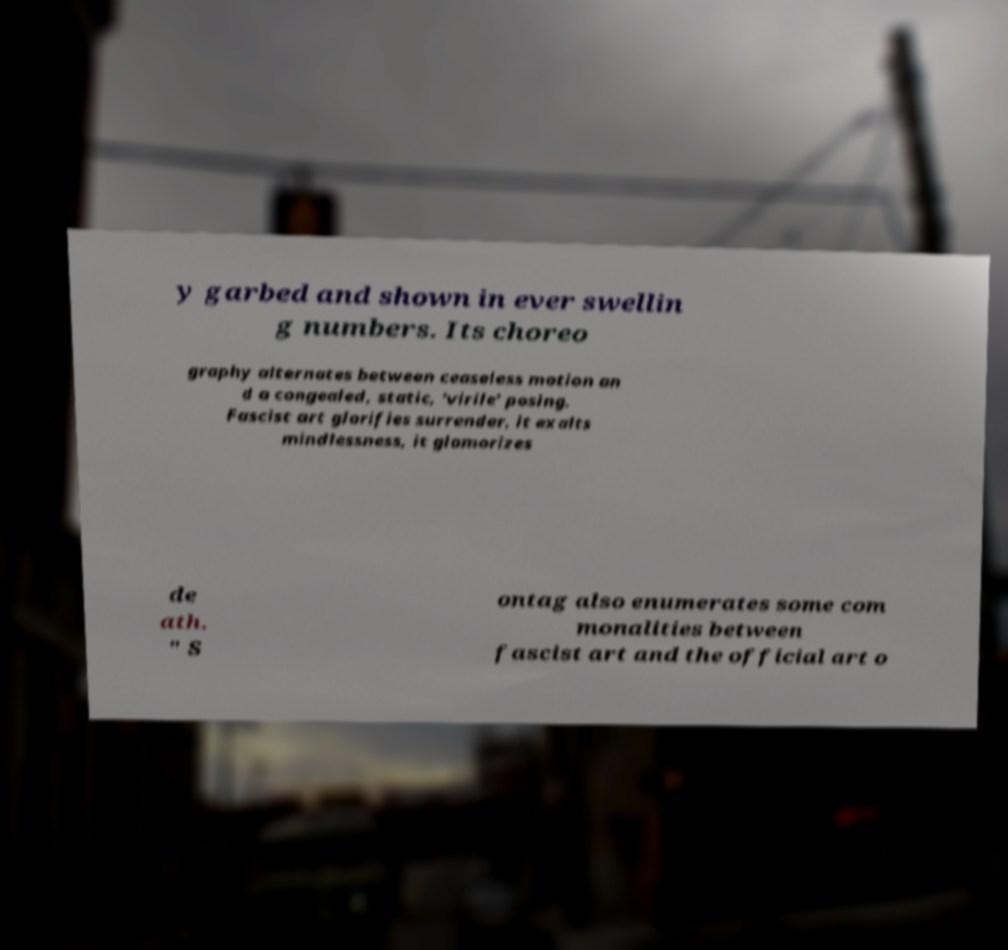Could you assist in decoding the text presented in this image and type it out clearly? y garbed and shown in ever swellin g numbers. Its choreo graphy alternates between ceaseless motion an d a congealed, static, 'virile' posing. Fascist art glorifies surrender, it exalts mindlessness, it glamorizes de ath. " S ontag also enumerates some com monalities between fascist art and the official art o 